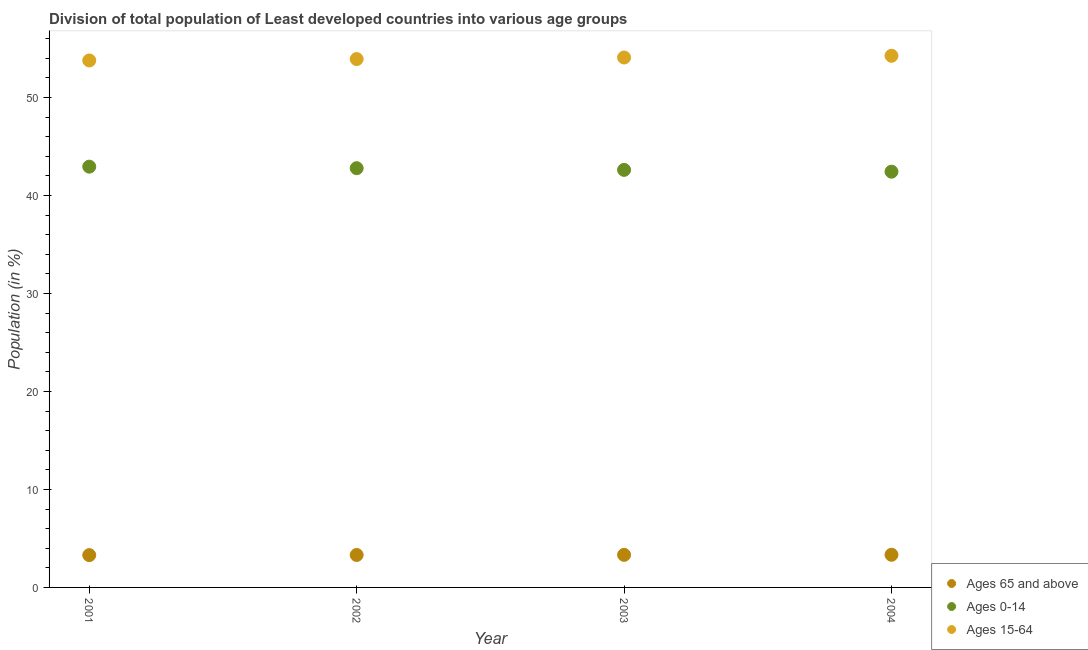Is the number of dotlines equal to the number of legend labels?
Ensure brevity in your answer.  Yes. What is the percentage of population within the age-group 15-64 in 2003?
Provide a short and direct response. 54.07. Across all years, what is the maximum percentage of population within the age-group of 65 and above?
Offer a terse response. 3.33. Across all years, what is the minimum percentage of population within the age-group 15-64?
Your answer should be compact. 53.77. In which year was the percentage of population within the age-group 0-14 maximum?
Your answer should be very brief. 2001. What is the total percentage of population within the age-group 0-14 in the graph?
Keep it short and to the point. 170.74. What is the difference between the percentage of population within the age-group 15-64 in 2002 and that in 2004?
Offer a very short reply. -0.33. What is the difference between the percentage of population within the age-group of 65 and above in 2003 and the percentage of population within the age-group 15-64 in 2001?
Provide a short and direct response. -50.45. What is the average percentage of population within the age-group of 65 and above per year?
Keep it short and to the point. 3.32. In the year 2001, what is the difference between the percentage of population within the age-group 15-64 and percentage of population within the age-group of 65 and above?
Make the answer very short. 50.47. In how many years, is the percentage of population within the age-group 15-64 greater than 2 %?
Offer a very short reply. 4. What is the ratio of the percentage of population within the age-group 15-64 in 2001 to that in 2003?
Your answer should be very brief. 0.99. Is the percentage of population within the age-group 15-64 in 2001 less than that in 2004?
Offer a terse response. Yes. Is the difference between the percentage of population within the age-group 15-64 in 2001 and 2004 greater than the difference between the percentage of population within the age-group 0-14 in 2001 and 2004?
Make the answer very short. No. What is the difference between the highest and the second highest percentage of population within the age-group 15-64?
Offer a very short reply. 0.17. What is the difference between the highest and the lowest percentage of population within the age-group of 65 and above?
Your response must be concise. 0.04. In how many years, is the percentage of population within the age-group 0-14 greater than the average percentage of population within the age-group 0-14 taken over all years?
Give a very brief answer. 2. Does the percentage of population within the age-group 0-14 monotonically increase over the years?
Your answer should be compact. No. Is the percentage of population within the age-group 0-14 strictly less than the percentage of population within the age-group of 65 and above over the years?
Your answer should be very brief. No. How many dotlines are there?
Make the answer very short. 3. How many years are there in the graph?
Ensure brevity in your answer.  4. What is the difference between two consecutive major ticks on the Y-axis?
Your answer should be compact. 10. Are the values on the major ticks of Y-axis written in scientific E-notation?
Provide a succinct answer. No. Does the graph contain any zero values?
Keep it short and to the point. No. How many legend labels are there?
Give a very brief answer. 3. How are the legend labels stacked?
Give a very brief answer. Vertical. What is the title of the graph?
Provide a short and direct response. Division of total population of Least developed countries into various age groups
. Does "Textiles and clothing" appear as one of the legend labels in the graph?
Give a very brief answer. No. What is the label or title of the Y-axis?
Your answer should be compact. Population (in %). What is the Population (in %) of Ages 65 and above in 2001?
Offer a terse response. 3.3. What is the Population (in %) of Ages 0-14 in 2001?
Keep it short and to the point. 42.93. What is the Population (in %) in Ages 15-64 in 2001?
Offer a terse response. 53.77. What is the Population (in %) of Ages 65 and above in 2002?
Offer a terse response. 3.31. What is the Population (in %) in Ages 0-14 in 2002?
Provide a succinct answer. 42.78. What is the Population (in %) in Ages 15-64 in 2002?
Ensure brevity in your answer.  53.91. What is the Population (in %) of Ages 65 and above in 2003?
Your answer should be very brief. 3.32. What is the Population (in %) in Ages 0-14 in 2003?
Give a very brief answer. 42.6. What is the Population (in %) of Ages 15-64 in 2003?
Offer a very short reply. 54.07. What is the Population (in %) of Ages 65 and above in 2004?
Your answer should be compact. 3.33. What is the Population (in %) of Ages 0-14 in 2004?
Keep it short and to the point. 42.42. What is the Population (in %) of Ages 15-64 in 2004?
Provide a short and direct response. 54.25. Across all years, what is the maximum Population (in %) in Ages 65 and above?
Keep it short and to the point. 3.33. Across all years, what is the maximum Population (in %) in Ages 0-14?
Give a very brief answer. 42.93. Across all years, what is the maximum Population (in %) of Ages 15-64?
Offer a very short reply. 54.25. Across all years, what is the minimum Population (in %) of Ages 65 and above?
Provide a short and direct response. 3.3. Across all years, what is the minimum Population (in %) in Ages 0-14?
Keep it short and to the point. 42.42. Across all years, what is the minimum Population (in %) of Ages 15-64?
Make the answer very short. 53.77. What is the total Population (in %) in Ages 65 and above in the graph?
Provide a succinct answer. 13.26. What is the total Population (in %) in Ages 0-14 in the graph?
Give a very brief answer. 170.74. What is the total Population (in %) of Ages 15-64 in the graph?
Give a very brief answer. 216. What is the difference between the Population (in %) in Ages 65 and above in 2001 and that in 2002?
Ensure brevity in your answer.  -0.02. What is the difference between the Population (in %) of Ages 0-14 in 2001 and that in 2002?
Your answer should be very brief. 0.16. What is the difference between the Population (in %) in Ages 15-64 in 2001 and that in 2002?
Provide a succinct answer. -0.14. What is the difference between the Population (in %) of Ages 65 and above in 2001 and that in 2003?
Your response must be concise. -0.03. What is the difference between the Population (in %) in Ages 0-14 in 2001 and that in 2003?
Give a very brief answer. 0.33. What is the difference between the Population (in %) of Ages 15-64 in 2001 and that in 2003?
Ensure brevity in your answer.  -0.3. What is the difference between the Population (in %) of Ages 65 and above in 2001 and that in 2004?
Keep it short and to the point. -0.04. What is the difference between the Population (in %) in Ages 0-14 in 2001 and that in 2004?
Offer a very short reply. 0.51. What is the difference between the Population (in %) of Ages 15-64 in 2001 and that in 2004?
Your answer should be very brief. -0.48. What is the difference between the Population (in %) of Ages 65 and above in 2002 and that in 2003?
Provide a succinct answer. -0.01. What is the difference between the Population (in %) in Ages 0-14 in 2002 and that in 2003?
Your answer should be compact. 0.17. What is the difference between the Population (in %) in Ages 15-64 in 2002 and that in 2003?
Your response must be concise. -0.16. What is the difference between the Population (in %) of Ages 65 and above in 2002 and that in 2004?
Give a very brief answer. -0.02. What is the difference between the Population (in %) of Ages 0-14 in 2002 and that in 2004?
Your response must be concise. 0.36. What is the difference between the Population (in %) of Ages 15-64 in 2002 and that in 2004?
Ensure brevity in your answer.  -0.33. What is the difference between the Population (in %) in Ages 65 and above in 2003 and that in 2004?
Offer a very short reply. -0.01. What is the difference between the Population (in %) of Ages 0-14 in 2003 and that in 2004?
Provide a short and direct response. 0.18. What is the difference between the Population (in %) in Ages 15-64 in 2003 and that in 2004?
Your answer should be very brief. -0.17. What is the difference between the Population (in %) of Ages 65 and above in 2001 and the Population (in %) of Ages 0-14 in 2002?
Give a very brief answer. -39.48. What is the difference between the Population (in %) of Ages 65 and above in 2001 and the Population (in %) of Ages 15-64 in 2002?
Your response must be concise. -50.62. What is the difference between the Population (in %) in Ages 0-14 in 2001 and the Population (in %) in Ages 15-64 in 2002?
Offer a very short reply. -10.98. What is the difference between the Population (in %) of Ages 65 and above in 2001 and the Population (in %) of Ages 0-14 in 2003?
Offer a terse response. -39.31. What is the difference between the Population (in %) of Ages 65 and above in 2001 and the Population (in %) of Ages 15-64 in 2003?
Make the answer very short. -50.78. What is the difference between the Population (in %) of Ages 0-14 in 2001 and the Population (in %) of Ages 15-64 in 2003?
Ensure brevity in your answer.  -11.14. What is the difference between the Population (in %) of Ages 65 and above in 2001 and the Population (in %) of Ages 0-14 in 2004?
Your answer should be compact. -39.12. What is the difference between the Population (in %) of Ages 65 and above in 2001 and the Population (in %) of Ages 15-64 in 2004?
Keep it short and to the point. -50.95. What is the difference between the Population (in %) of Ages 0-14 in 2001 and the Population (in %) of Ages 15-64 in 2004?
Provide a succinct answer. -11.31. What is the difference between the Population (in %) in Ages 65 and above in 2002 and the Population (in %) in Ages 0-14 in 2003?
Provide a short and direct response. -39.29. What is the difference between the Population (in %) of Ages 65 and above in 2002 and the Population (in %) of Ages 15-64 in 2003?
Your answer should be compact. -50.76. What is the difference between the Population (in %) of Ages 0-14 in 2002 and the Population (in %) of Ages 15-64 in 2003?
Provide a succinct answer. -11.3. What is the difference between the Population (in %) in Ages 65 and above in 2002 and the Population (in %) in Ages 0-14 in 2004?
Your answer should be compact. -39.11. What is the difference between the Population (in %) of Ages 65 and above in 2002 and the Population (in %) of Ages 15-64 in 2004?
Offer a terse response. -50.93. What is the difference between the Population (in %) of Ages 0-14 in 2002 and the Population (in %) of Ages 15-64 in 2004?
Give a very brief answer. -11.47. What is the difference between the Population (in %) of Ages 65 and above in 2003 and the Population (in %) of Ages 0-14 in 2004?
Your answer should be compact. -39.1. What is the difference between the Population (in %) in Ages 65 and above in 2003 and the Population (in %) in Ages 15-64 in 2004?
Ensure brevity in your answer.  -50.92. What is the difference between the Population (in %) of Ages 0-14 in 2003 and the Population (in %) of Ages 15-64 in 2004?
Provide a succinct answer. -11.64. What is the average Population (in %) of Ages 65 and above per year?
Your response must be concise. 3.32. What is the average Population (in %) of Ages 0-14 per year?
Your answer should be very brief. 42.68. What is the average Population (in %) in Ages 15-64 per year?
Your answer should be compact. 54. In the year 2001, what is the difference between the Population (in %) of Ages 65 and above and Population (in %) of Ages 0-14?
Provide a succinct answer. -39.64. In the year 2001, what is the difference between the Population (in %) in Ages 65 and above and Population (in %) in Ages 15-64?
Ensure brevity in your answer.  -50.47. In the year 2001, what is the difference between the Population (in %) in Ages 0-14 and Population (in %) in Ages 15-64?
Make the answer very short. -10.83. In the year 2002, what is the difference between the Population (in %) in Ages 65 and above and Population (in %) in Ages 0-14?
Give a very brief answer. -39.47. In the year 2002, what is the difference between the Population (in %) in Ages 65 and above and Population (in %) in Ages 15-64?
Keep it short and to the point. -50.6. In the year 2002, what is the difference between the Population (in %) in Ages 0-14 and Population (in %) in Ages 15-64?
Offer a very short reply. -11.13. In the year 2003, what is the difference between the Population (in %) in Ages 65 and above and Population (in %) in Ages 0-14?
Ensure brevity in your answer.  -39.28. In the year 2003, what is the difference between the Population (in %) of Ages 65 and above and Population (in %) of Ages 15-64?
Give a very brief answer. -50.75. In the year 2003, what is the difference between the Population (in %) of Ages 0-14 and Population (in %) of Ages 15-64?
Offer a terse response. -11.47. In the year 2004, what is the difference between the Population (in %) of Ages 65 and above and Population (in %) of Ages 0-14?
Offer a very short reply. -39.09. In the year 2004, what is the difference between the Population (in %) in Ages 65 and above and Population (in %) in Ages 15-64?
Offer a terse response. -50.91. In the year 2004, what is the difference between the Population (in %) of Ages 0-14 and Population (in %) of Ages 15-64?
Make the answer very short. -11.82. What is the ratio of the Population (in %) in Ages 65 and above in 2001 to that in 2002?
Provide a succinct answer. 1. What is the ratio of the Population (in %) of Ages 15-64 in 2001 to that in 2002?
Your response must be concise. 1. What is the ratio of the Population (in %) of Ages 65 and above in 2001 to that in 2003?
Ensure brevity in your answer.  0.99. What is the ratio of the Population (in %) of Ages 0-14 in 2001 to that in 2003?
Your response must be concise. 1.01. What is the ratio of the Population (in %) in Ages 0-14 in 2001 to that in 2004?
Keep it short and to the point. 1.01. What is the ratio of the Population (in %) of Ages 65 and above in 2002 to that in 2003?
Keep it short and to the point. 1. What is the ratio of the Population (in %) of Ages 15-64 in 2002 to that in 2003?
Offer a terse response. 1. What is the ratio of the Population (in %) in Ages 65 and above in 2002 to that in 2004?
Offer a terse response. 0.99. What is the ratio of the Population (in %) of Ages 0-14 in 2002 to that in 2004?
Make the answer very short. 1.01. What is the ratio of the Population (in %) of Ages 15-64 in 2002 to that in 2004?
Provide a succinct answer. 0.99. What is the ratio of the Population (in %) of Ages 0-14 in 2003 to that in 2004?
Offer a very short reply. 1. What is the difference between the highest and the second highest Population (in %) of Ages 65 and above?
Give a very brief answer. 0.01. What is the difference between the highest and the second highest Population (in %) in Ages 0-14?
Your answer should be very brief. 0.16. What is the difference between the highest and the second highest Population (in %) of Ages 15-64?
Give a very brief answer. 0.17. What is the difference between the highest and the lowest Population (in %) in Ages 65 and above?
Provide a short and direct response. 0.04. What is the difference between the highest and the lowest Population (in %) of Ages 0-14?
Ensure brevity in your answer.  0.51. What is the difference between the highest and the lowest Population (in %) in Ages 15-64?
Keep it short and to the point. 0.48. 